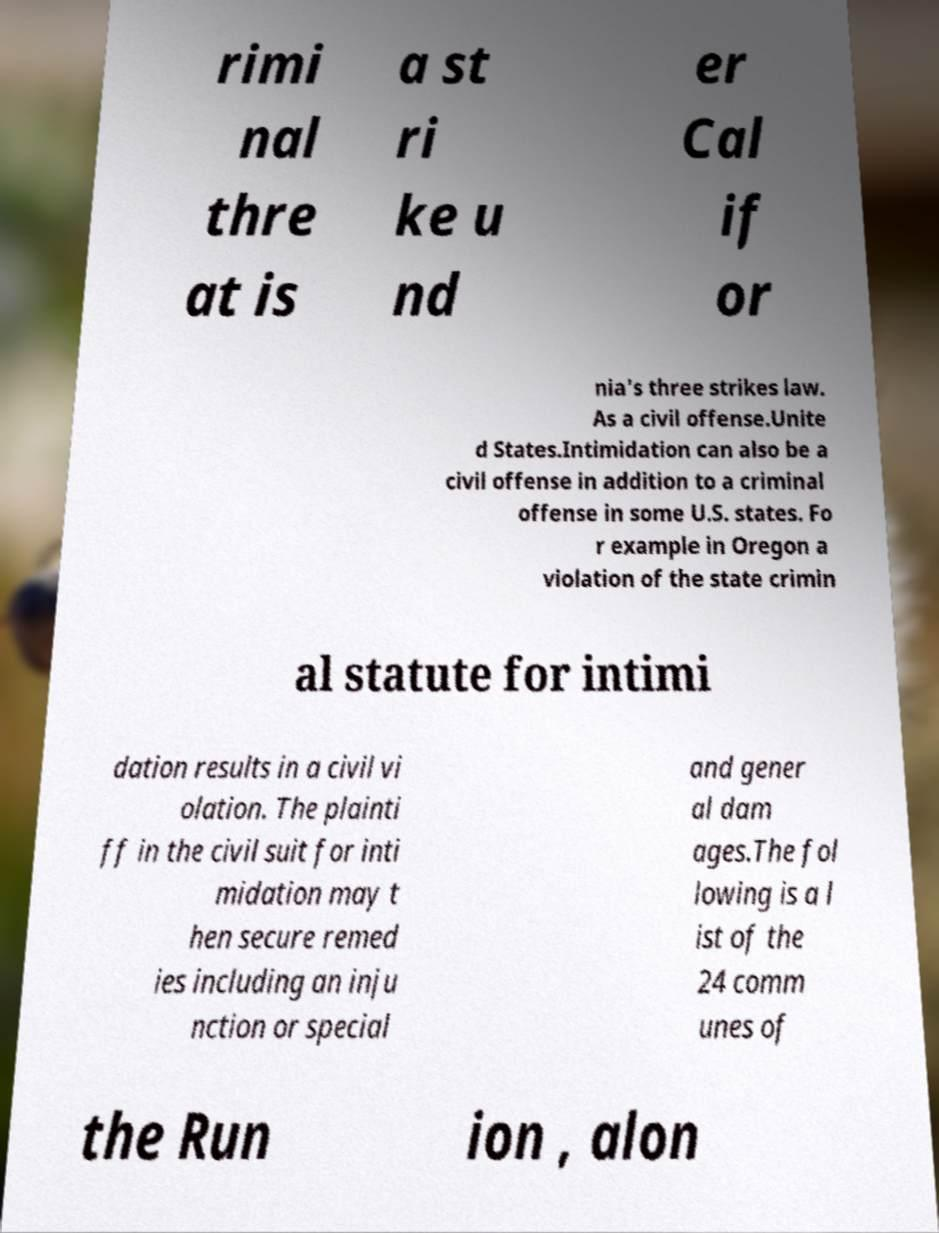Can you accurately transcribe the text from the provided image for me? rimi nal thre at is a st ri ke u nd er Cal if or nia's three strikes law. As a civil offense.Unite d States.Intimidation can also be a civil offense in addition to a criminal offense in some U.S. states. Fo r example in Oregon a violation of the state crimin al statute for intimi dation results in a civil vi olation. The plainti ff in the civil suit for inti midation may t hen secure remed ies including an inju nction or special and gener al dam ages.The fol lowing is a l ist of the 24 comm unes of the Run ion , alon 